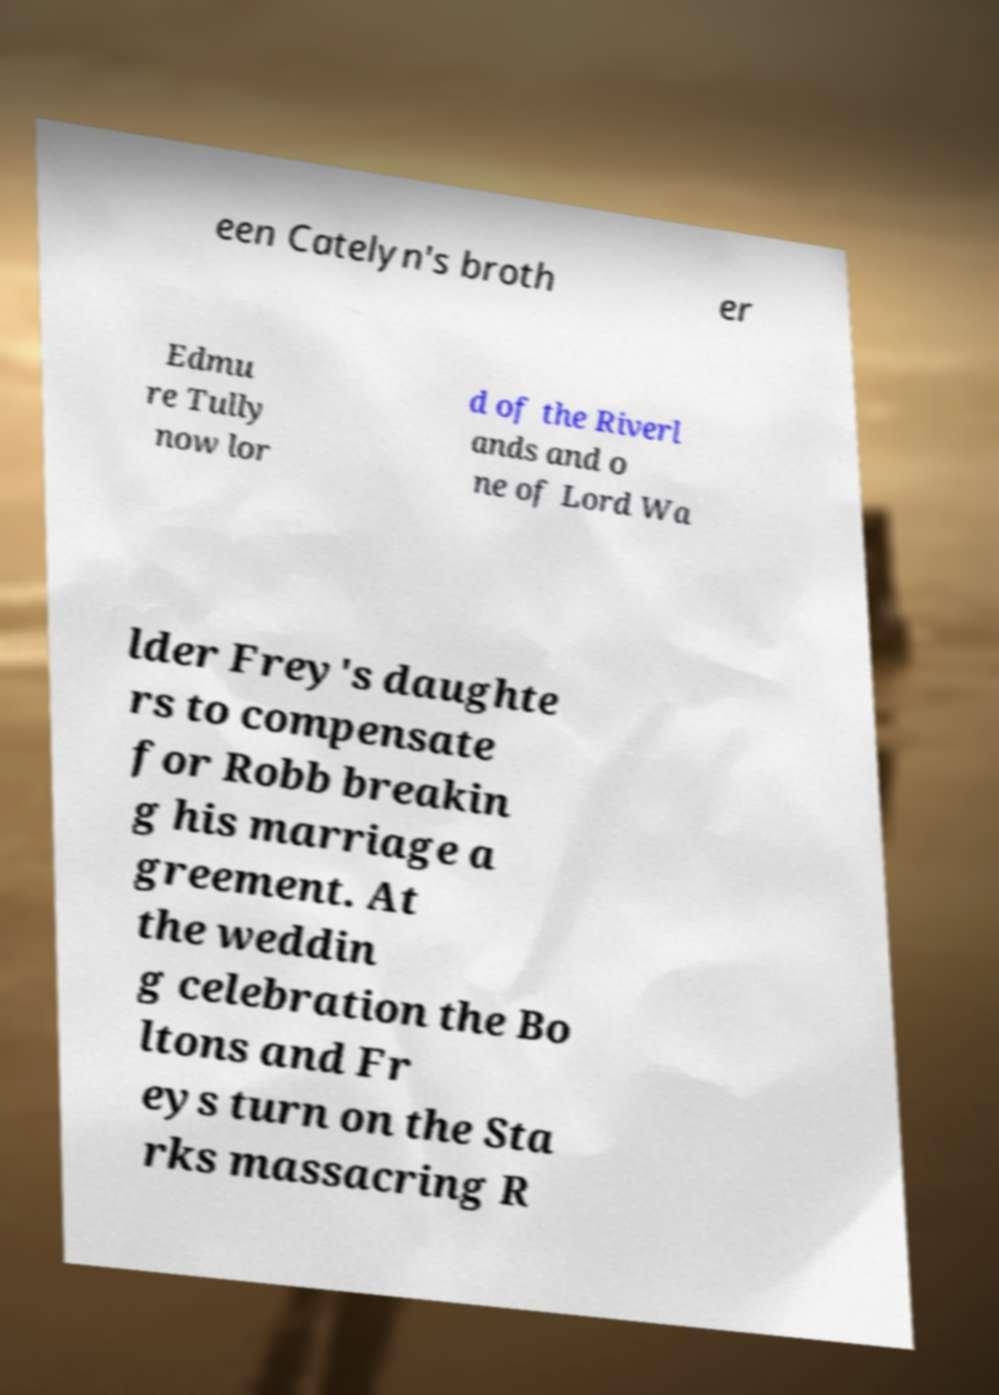Can you read and provide the text displayed in the image?This photo seems to have some interesting text. Can you extract and type it out for me? een Catelyn's broth er Edmu re Tully now lor d of the Riverl ands and o ne of Lord Wa lder Frey's daughte rs to compensate for Robb breakin g his marriage a greement. At the weddin g celebration the Bo ltons and Fr eys turn on the Sta rks massacring R 